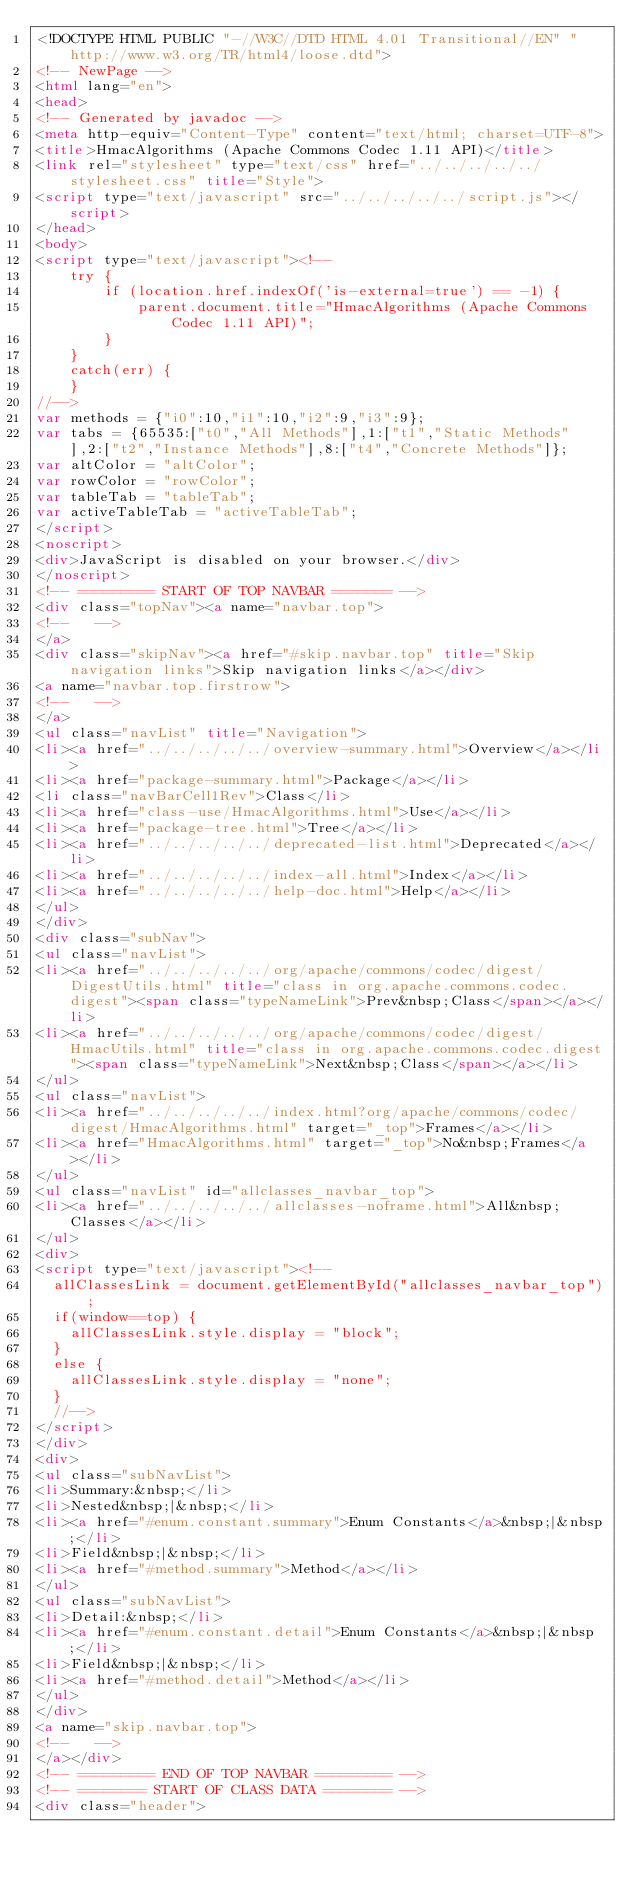<code> <loc_0><loc_0><loc_500><loc_500><_HTML_><!DOCTYPE HTML PUBLIC "-//W3C//DTD HTML 4.01 Transitional//EN" "http://www.w3.org/TR/html4/loose.dtd">
<!-- NewPage -->
<html lang="en">
<head>
<!-- Generated by javadoc -->
<meta http-equiv="Content-Type" content="text/html; charset=UTF-8">
<title>HmacAlgorithms (Apache Commons Codec 1.11 API)</title>
<link rel="stylesheet" type="text/css" href="../../../../../stylesheet.css" title="Style">
<script type="text/javascript" src="../../../../../script.js"></script>
</head>
<body>
<script type="text/javascript"><!--
    try {
        if (location.href.indexOf('is-external=true') == -1) {
            parent.document.title="HmacAlgorithms (Apache Commons Codec 1.11 API)";
        }
    }
    catch(err) {
    }
//-->
var methods = {"i0":10,"i1":10,"i2":9,"i3":9};
var tabs = {65535:["t0","All Methods"],1:["t1","Static Methods"],2:["t2","Instance Methods"],8:["t4","Concrete Methods"]};
var altColor = "altColor";
var rowColor = "rowColor";
var tableTab = "tableTab";
var activeTableTab = "activeTableTab";
</script>
<noscript>
<div>JavaScript is disabled on your browser.</div>
</noscript>
<!-- ========= START OF TOP NAVBAR ======= -->
<div class="topNav"><a name="navbar.top">
<!--   -->
</a>
<div class="skipNav"><a href="#skip.navbar.top" title="Skip navigation links">Skip navigation links</a></div>
<a name="navbar.top.firstrow">
<!--   -->
</a>
<ul class="navList" title="Navigation">
<li><a href="../../../../../overview-summary.html">Overview</a></li>
<li><a href="package-summary.html">Package</a></li>
<li class="navBarCell1Rev">Class</li>
<li><a href="class-use/HmacAlgorithms.html">Use</a></li>
<li><a href="package-tree.html">Tree</a></li>
<li><a href="../../../../../deprecated-list.html">Deprecated</a></li>
<li><a href="../../../../../index-all.html">Index</a></li>
<li><a href="../../../../../help-doc.html">Help</a></li>
</ul>
</div>
<div class="subNav">
<ul class="navList">
<li><a href="../../../../../org/apache/commons/codec/digest/DigestUtils.html" title="class in org.apache.commons.codec.digest"><span class="typeNameLink">Prev&nbsp;Class</span></a></li>
<li><a href="../../../../../org/apache/commons/codec/digest/HmacUtils.html" title="class in org.apache.commons.codec.digest"><span class="typeNameLink">Next&nbsp;Class</span></a></li>
</ul>
<ul class="navList">
<li><a href="../../../../../index.html?org/apache/commons/codec/digest/HmacAlgorithms.html" target="_top">Frames</a></li>
<li><a href="HmacAlgorithms.html" target="_top">No&nbsp;Frames</a></li>
</ul>
<ul class="navList" id="allclasses_navbar_top">
<li><a href="../../../../../allclasses-noframe.html">All&nbsp;Classes</a></li>
</ul>
<div>
<script type="text/javascript"><!--
  allClassesLink = document.getElementById("allclasses_navbar_top");
  if(window==top) {
    allClassesLink.style.display = "block";
  }
  else {
    allClassesLink.style.display = "none";
  }
  //-->
</script>
</div>
<div>
<ul class="subNavList">
<li>Summary:&nbsp;</li>
<li>Nested&nbsp;|&nbsp;</li>
<li><a href="#enum.constant.summary">Enum Constants</a>&nbsp;|&nbsp;</li>
<li>Field&nbsp;|&nbsp;</li>
<li><a href="#method.summary">Method</a></li>
</ul>
<ul class="subNavList">
<li>Detail:&nbsp;</li>
<li><a href="#enum.constant.detail">Enum Constants</a>&nbsp;|&nbsp;</li>
<li>Field&nbsp;|&nbsp;</li>
<li><a href="#method.detail">Method</a></li>
</ul>
</div>
<a name="skip.navbar.top">
<!--   -->
</a></div>
<!-- ========= END OF TOP NAVBAR ========= -->
<!-- ======== START OF CLASS DATA ======== -->
<div class="header"></code> 